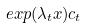<formula> <loc_0><loc_0><loc_500><loc_500>e x p ( \lambda _ { t } x ) c _ { t }</formula> 